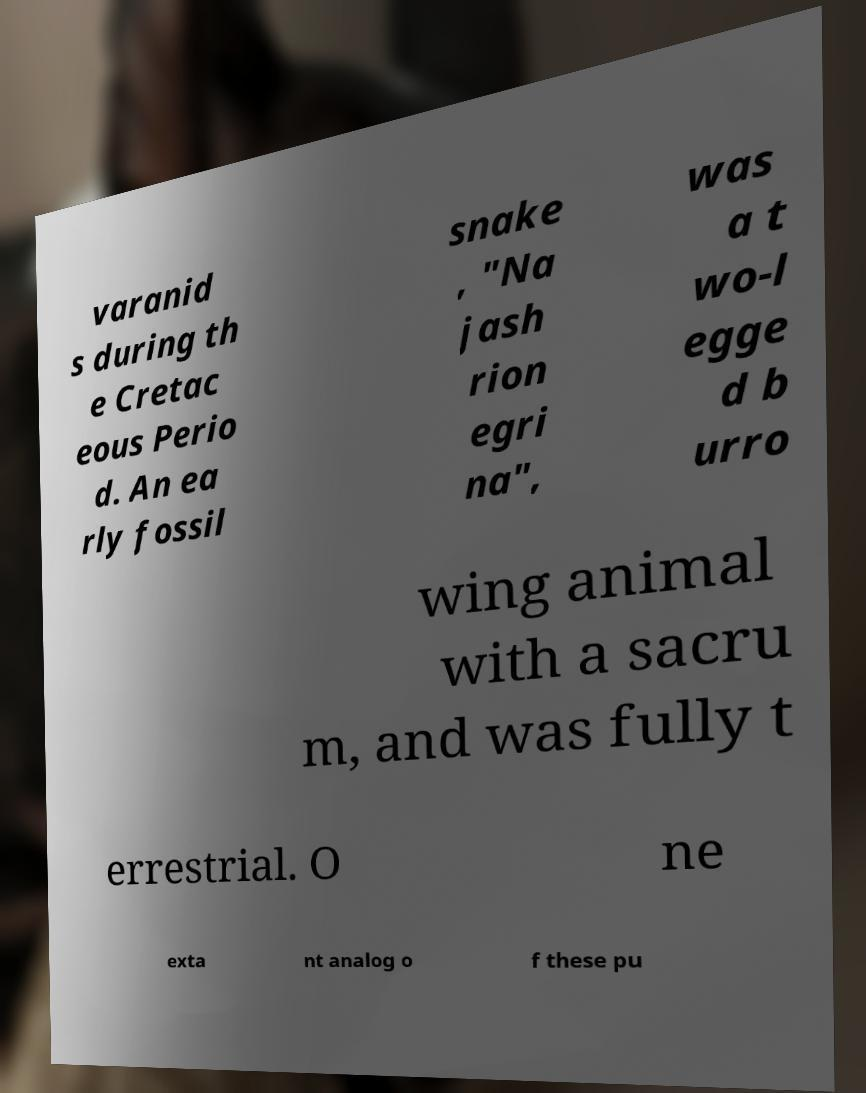I need the written content from this picture converted into text. Can you do that? varanid s during th e Cretac eous Perio d. An ea rly fossil snake , "Na jash rion egri na", was a t wo-l egge d b urro wing animal with a sacru m, and was fully t errestrial. O ne exta nt analog o f these pu 